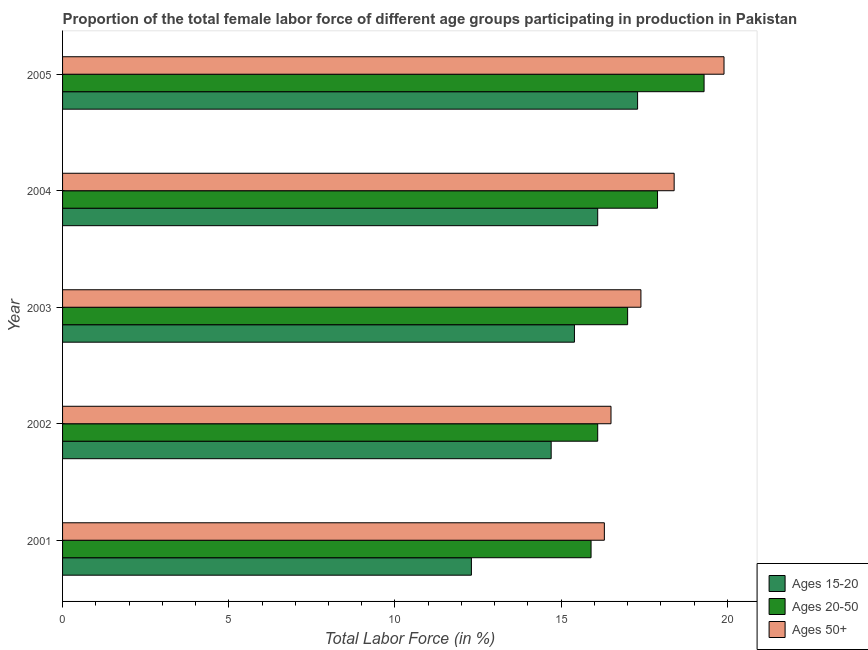How many different coloured bars are there?
Give a very brief answer. 3. How many groups of bars are there?
Offer a very short reply. 5. Are the number of bars per tick equal to the number of legend labels?
Your answer should be compact. Yes. Are the number of bars on each tick of the Y-axis equal?
Your answer should be very brief. Yes. How many bars are there on the 4th tick from the top?
Keep it short and to the point. 3. How many bars are there on the 2nd tick from the bottom?
Give a very brief answer. 3. What is the percentage of female labor force within the age group 15-20 in 2001?
Provide a short and direct response. 12.3. Across all years, what is the maximum percentage of female labor force within the age group 20-50?
Offer a very short reply. 19.3. Across all years, what is the minimum percentage of female labor force within the age group 15-20?
Offer a very short reply. 12.3. What is the total percentage of female labor force above age 50 in the graph?
Your answer should be very brief. 88.5. What is the difference between the percentage of female labor force within the age group 20-50 in 2005 and the percentage of female labor force above age 50 in 2002?
Keep it short and to the point. 2.8. What is the average percentage of female labor force within the age group 20-50 per year?
Provide a short and direct response. 17.24. What is the ratio of the percentage of female labor force above age 50 in 2001 to that in 2004?
Offer a terse response. 0.89. Is the percentage of female labor force within the age group 20-50 in 2004 less than that in 2005?
Your answer should be very brief. Yes. What is the difference between the highest and the second highest percentage of female labor force within the age group 15-20?
Your answer should be very brief. 1.2. What is the difference between the highest and the lowest percentage of female labor force within the age group 20-50?
Your answer should be very brief. 3.4. In how many years, is the percentage of female labor force within the age group 15-20 greater than the average percentage of female labor force within the age group 15-20 taken over all years?
Offer a very short reply. 3. What does the 2nd bar from the top in 2001 represents?
Provide a succinct answer. Ages 20-50. What does the 2nd bar from the bottom in 2005 represents?
Offer a very short reply. Ages 20-50. How many bars are there?
Provide a short and direct response. 15. How many years are there in the graph?
Your answer should be very brief. 5. What is the difference between two consecutive major ticks on the X-axis?
Provide a succinct answer. 5. Are the values on the major ticks of X-axis written in scientific E-notation?
Offer a very short reply. No. Does the graph contain any zero values?
Ensure brevity in your answer.  No. Does the graph contain grids?
Offer a terse response. No. How many legend labels are there?
Offer a terse response. 3. How are the legend labels stacked?
Your answer should be compact. Vertical. What is the title of the graph?
Your response must be concise. Proportion of the total female labor force of different age groups participating in production in Pakistan. What is the label or title of the Y-axis?
Your answer should be compact. Year. What is the Total Labor Force (in %) of Ages 15-20 in 2001?
Ensure brevity in your answer.  12.3. What is the Total Labor Force (in %) in Ages 20-50 in 2001?
Your answer should be very brief. 15.9. What is the Total Labor Force (in %) of Ages 50+ in 2001?
Your response must be concise. 16.3. What is the Total Labor Force (in %) in Ages 15-20 in 2002?
Provide a short and direct response. 14.7. What is the Total Labor Force (in %) in Ages 20-50 in 2002?
Provide a short and direct response. 16.1. What is the Total Labor Force (in %) in Ages 50+ in 2002?
Offer a very short reply. 16.5. What is the Total Labor Force (in %) in Ages 15-20 in 2003?
Offer a terse response. 15.4. What is the Total Labor Force (in %) in Ages 20-50 in 2003?
Ensure brevity in your answer.  17. What is the Total Labor Force (in %) in Ages 50+ in 2003?
Provide a succinct answer. 17.4. What is the Total Labor Force (in %) in Ages 15-20 in 2004?
Make the answer very short. 16.1. What is the Total Labor Force (in %) in Ages 20-50 in 2004?
Your answer should be very brief. 17.9. What is the Total Labor Force (in %) of Ages 50+ in 2004?
Provide a short and direct response. 18.4. What is the Total Labor Force (in %) in Ages 15-20 in 2005?
Your response must be concise. 17.3. What is the Total Labor Force (in %) in Ages 20-50 in 2005?
Make the answer very short. 19.3. What is the Total Labor Force (in %) of Ages 50+ in 2005?
Make the answer very short. 19.9. Across all years, what is the maximum Total Labor Force (in %) of Ages 15-20?
Make the answer very short. 17.3. Across all years, what is the maximum Total Labor Force (in %) in Ages 20-50?
Provide a short and direct response. 19.3. Across all years, what is the maximum Total Labor Force (in %) of Ages 50+?
Give a very brief answer. 19.9. Across all years, what is the minimum Total Labor Force (in %) of Ages 15-20?
Your answer should be very brief. 12.3. Across all years, what is the minimum Total Labor Force (in %) of Ages 20-50?
Make the answer very short. 15.9. Across all years, what is the minimum Total Labor Force (in %) of Ages 50+?
Ensure brevity in your answer.  16.3. What is the total Total Labor Force (in %) in Ages 15-20 in the graph?
Your answer should be compact. 75.8. What is the total Total Labor Force (in %) of Ages 20-50 in the graph?
Your response must be concise. 86.2. What is the total Total Labor Force (in %) in Ages 50+ in the graph?
Provide a succinct answer. 88.5. What is the difference between the Total Labor Force (in %) in Ages 15-20 in 2001 and that in 2002?
Provide a succinct answer. -2.4. What is the difference between the Total Labor Force (in %) in Ages 20-50 in 2001 and that in 2003?
Offer a terse response. -1.1. What is the difference between the Total Labor Force (in %) of Ages 50+ in 2001 and that in 2004?
Offer a terse response. -2.1. What is the difference between the Total Labor Force (in %) in Ages 20-50 in 2001 and that in 2005?
Offer a terse response. -3.4. What is the difference between the Total Labor Force (in %) of Ages 50+ in 2001 and that in 2005?
Give a very brief answer. -3.6. What is the difference between the Total Labor Force (in %) in Ages 15-20 in 2002 and that in 2003?
Your response must be concise. -0.7. What is the difference between the Total Labor Force (in %) of Ages 20-50 in 2002 and that in 2003?
Ensure brevity in your answer.  -0.9. What is the difference between the Total Labor Force (in %) in Ages 20-50 in 2002 and that in 2004?
Your answer should be compact. -1.8. What is the difference between the Total Labor Force (in %) of Ages 15-20 in 2002 and that in 2005?
Provide a succinct answer. -2.6. What is the difference between the Total Labor Force (in %) of Ages 15-20 in 2003 and that in 2004?
Keep it short and to the point. -0.7. What is the difference between the Total Labor Force (in %) in Ages 20-50 in 2003 and that in 2005?
Provide a short and direct response. -2.3. What is the difference between the Total Labor Force (in %) in Ages 50+ in 2003 and that in 2005?
Keep it short and to the point. -2.5. What is the difference between the Total Labor Force (in %) of Ages 15-20 in 2004 and that in 2005?
Keep it short and to the point. -1.2. What is the difference between the Total Labor Force (in %) in Ages 15-20 in 2001 and the Total Labor Force (in %) in Ages 20-50 in 2002?
Keep it short and to the point. -3.8. What is the difference between the Total Labor Force (in %) of Ages 15-20 in 2001 and the Total Labor Force (in %) of Ages 50+ in 2002?
Provide a short and direct response. -4.2. What is the difference between the Total Labor Force (in %) in Ages 15-20 in 2001 and the Total Labor Force (in %) in Ages 20-50 in 2003?
Keep it short and to the point. -4.7. What is the difference between the Total Labor Force (in %) in Ages 15-20 in 2001 and the Total Labor Force (in %) in Ages 50+ in 2003?
Make the answer very short. -5.1. What is the difference between the Total Labor Force (in %) in Ages 15-20 in 2001 and the Total Labor Force (in %) in Ages 20-50 in 2004?
Provide a short and direct response. -5.6. What is the difference between the Total Labor Force (in %) in Ages 15-20 in 2001 and the Total Labor Force (in %) in Ages 50+ in 2004?
Give a very brief answer. -6.1. What is the difference between the Total Labor Force (in %) of Ages 20-50 in 2001 and the Total Labor Force (in %) of Ages 50+ in 2004?
Provide a succinct answer. -2.5. What is the difference between the Total Labor Force (in %) in Ages 15-20 in 2001 and the Total Labor Force (in %) in Ages 20-50 in 2005?
Offer a terse response. -7. What is the difference between the Total Labor Force (in %) in Ages 20-50 in 2001 and the Total Labor Force (in %) in Ages 50+ in 2005?
Your answer should be very brief. -4. What is the difference between the Total Labor Force (in %) in Ages 15-20 in 2002 and the Total Labor Force (in %) in Ages 50+ in 2003?
Offer a terse response. -2.7. What is the difference between the Total Labor Force (in %) in Ages 15-20 in 2002 and the Total Labor Force (in %) in Ages 50+ in 2004?
Provide a short and direct response. -3.7. What is the difference between the Total Labor Force (in %) in Ages 20-50 in 2002 and the Total Labor Force (in %) in Ages 50+ in 2004?
Your answer should be very brief. -2.3. What is the difference between the Total Labor Force (in %) in Ages 15-20 in 2002 and the Total Labor Force (in %) in Ages 50+ in 2005?
Your answer should be compact. -5.2. What is the difference between the Total Labor Force (in %) of Ages 20-50 in 2002 and the Total Labor Force (in %) of Ages 50+ in 2005?
Your response must be concise. -3.8. What is the difference between the Total Labor Force (in %) in Ages 15-20 in 2003 and the Total Labor Force (in %) in Ages 50+ in 2004?
Your answer should be compact. -3. What is the difference between the Total Labor Force (in %) of Ages 15-20 in 2003 and the Total Labor Force (in %) of Ages 20-50 in 2005?
Your answer should be very brief. -3.9. What is the difference between the Total Labor Force (in %) in Ages 20-50 in 2003 and the Total Labor Force (in %) in Ages 50+ in 2005?
Your answer should be very brief. -2.9. What is the difference between the Total Labor Force (in %) in Ages 15-20 in 2004 and the Total Labor Force (in %) in Ages 20-50 in 2005?
Your answer should be very brief. -3.2. What is the difference between the Total Labor Force (in %) in Ages 15-20 in 2004 and the Total Labor Force (in %) in Ages 50+ in 2005?
Keep it short and to the point. -3.8. What is the average Total Labor Force (in %) of Ages 15-20 per year?
Your response must be concise. 15.16. What is the average Total Labor Force (in %) of Ages 20-50 per year?
Ensure brevity in your answer.  17.24. In the year 2001, what is the difference between the Total Labor Force (in %) of Ages 20-50 and Total Labor Force (in %) of Ages 50+?
Your answer should be very brief. -0.4. In the year 2002, what is the difference between the Total Labor Force (in %) of Ages 15-20 and Total Labor Force (in %) of Ages 20-50?
Make the answer very short. -1.4. In the year 2002, what is the difference between the Total Labor Force (in %) of Ages 15-20 and Total Labor Force (in %) of Ages 50+?
Offer a terse response. -1.8. In the year 2002, what is the difference between the Total Labor Force (in %) in Ages 20-50 and Total Labor Force (in %) in Ages 50+?
Give a very brief answer. -0.4. In the year 2003, what is the difference between the Total Labor Force (in %) in Ages 15-20 and Total Labor Force (in %) in Ages 50+?
Keep it short and to the point. -2. In the year 2003, what is the difference between the Total Labor Force (in %) of Ages 20-50 and Total Labor Force (in %) of Ages 50+?
Offer a terse response. -0.4. In the year 2004, what is the difference between the Total Labor Force (in %) of Ages 15-20 and Total Labor Force (in %) of Ages 50+?
Provide a succinct answer. -2.3. In the year 2005, what is the difference between the Total Labor Force (in %) of Ages 15-20 and Total Labor Force (in %) of Ages 50+?
Make the answer very short. -2.6. In the year 2005, what is the difference between the Total Labor Force (in %) of Ages 20-50 and Total Labor Force (in %) of Ages 50+?
Offer a very short reply. -0.6. What is the ratio of the Total Labor Force (in %) in Ages 15-20 in 2001 to that in 2002?
Give a very brief answer. 0.84. What is the ratio of the Total Labor Force (in %) of Ages 20-50 in 2001 to that in 2002?
Keep it short and to the point. 0.99. What is the ratio of the Total Labor Force (in %) in Ages 50+ in 2001 to that in 2002?
Give a very brief answer. 0.99. What is the ratio of the Total Labor Force (in %) in Ages 15-20 in 2001 to that in 2003?
Offer a very short reply. 0.8. What is the ratio of the Total Labor Force (in %) in Ages 20-50 in 2001 to that in 2003?
Provide a succinct answer. 0.94. What is the ratio of the Total Labor Force (in %) of Ages 50+ in 2001 to that in 2003?
Provide a short and direct response. 0.94. What is the ratio of the Total Labor Force (in %) in Ages 15-20 in 2001 to that in 2004?
Make the answer very short. 0.76. What is the ratio of the Total Labor Force (in %) of Ages 20-50 in 2001 to that in 2004?
Provide a succinct answer. 0.89. What is the ratio of the Total Labor Force (in %) of Ages 50+ in 2001 to that in 2004?
Your answer should be compact. 0.89. What is the ratio of the Total Labor Force (in %) of Ages 15-20 in 2001 to that in 2005?
Offer a very short reply. 0.71. What is the ratio of the Total Labor Force (in %) in Ages 20-50 in 2001 to that in 2005?
Ensure brevity in your answer.  0.82. What is the ratio of the Total Labor Force (in %) in Ages 50+ in 2001 to that in 2005?
Offer a very short reply. 0.82. What is the ratio of the Total Labor Force (in %) of Ages 15-20 in 2002 to that in 2003?
Your response must be concise. 0.95. What is the ratio of the Total Labor Force (in %) in Ages 20-50 in 2002 to that in 2003?
Your answer should be very brief. 0.95. What is the ratio of the Total Labor Force (in %) of Ages 50+ in 2002 to that in 2003?
Ensure brevity in your answer.  0.95. What is the ratio of the Total Labor Force (in %) of Ages 20-50 in 2002 to that in 2004?
Keep it short and to the point. 0.9. What is the ratio of the Total Labor Force (in %) in Ages 50+ in 2002 to that in 2004?
Your response must be concise. 0.9. What is the ratio of the Total Labor Force (in %) of Ages 15-20 in 2002 to that in 2005?
Ensure brevity in your answer.  0.85. What is the ratio of the Total Labor Force (in %) in Ages 20-50 in 2002 to that in 2005?
Give a very brief answer. 0.83. What is the ratio of the Total Labor Force (in %) in Ages 50+ in 2002 to that in 2005?
Offer a very short reply. 0.83. What is the ratio of the Total Labor Force (in %) of Ages 15-20 in 2003 to that in 2004?
Provide a short and direct response. 0.96. What is the ratio of the Total Labor Force (in %) of Ages 20-50 in 2003 to that in 2004?
Offer a terse response. 0.95. What is the ratio of the Total Labor Force (in %) of Ages 50+ in 2003 to that in 2004?
Keep it short and to the point. 0.95. What is the ratio of the Total Labor Force (in %) of Ages 15-20 in 2003 to that in 2005?
Make the answer very short. 0.89. What is the ratio of the Total Labor Force (in %) in Ages 20-50 in 2003 to that in 2005?
Offer a very short reply. 0.88. What is the ratio of the Total Labor Force (in %) of Ages 50+ in 2003 to that in 2005?
Ensure brevity in your answer.  0.87. What is the ratio of the Total Labor Force (in %) of Ages 15-20 in 2004 to that in 2005?
Provide a short and direct response. 0.93. What is the ratio of the Total Labor Force (in %) of Ages 20-50 in 2004 to that in 2005?
Your answer should be compact. 0.93. What is the ratio of the Total Labor Force (in %) of Ages 50+ in 2004 to that in 2005?
Your response must be concise. 0.92. What is the difference between the highest and the second highest Total Labor Force (in %) of Ages 20-50?
Give a very brief answer. 1.4. What is the difference between the highest and the lowest Total Labor Force (in %) in Ages 15-20?
Your response must be concise. 5. 